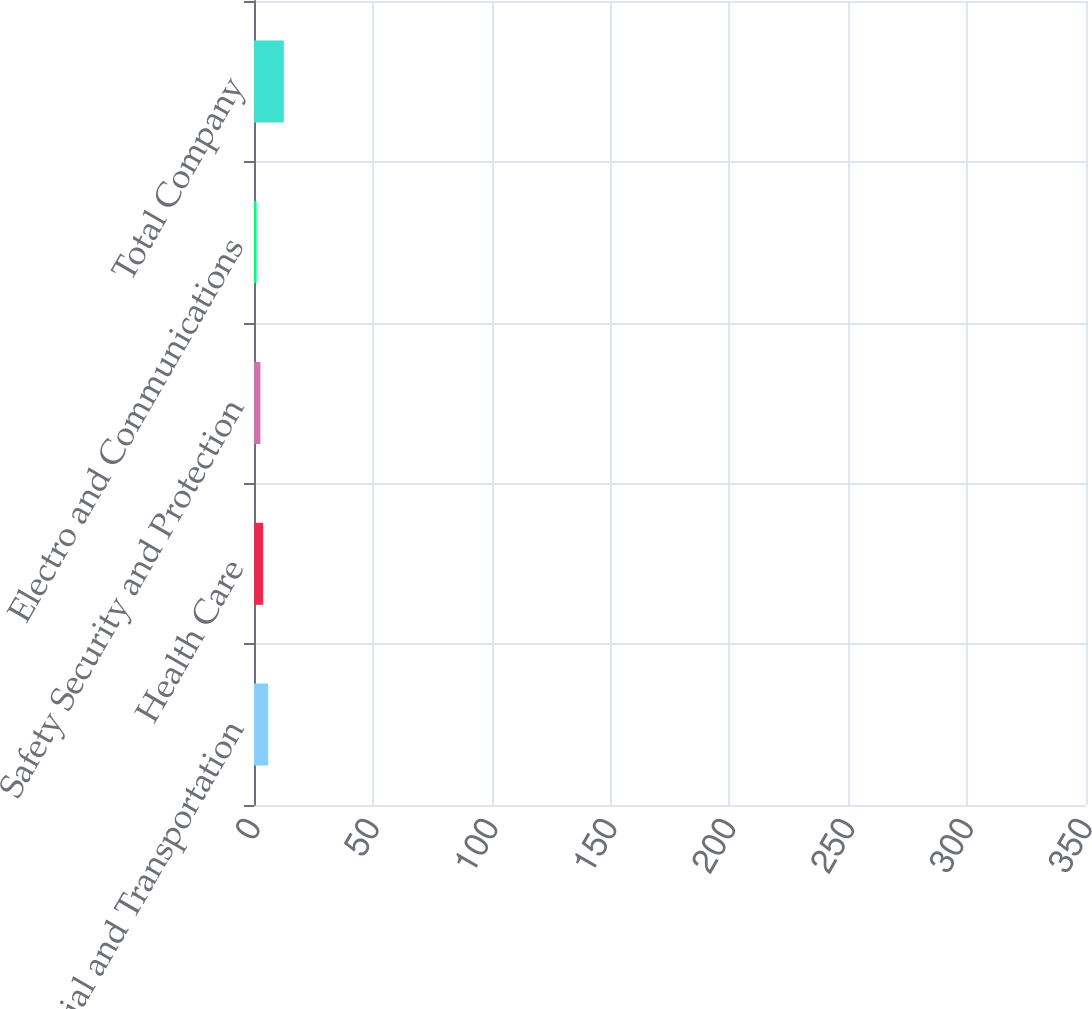Convert chart to OTSL. <chart><loc_0><loc_0><loc_500><loc_500><bar_chart><fcel>Industrial and Transportation<fcel>Health Care<fcel>Safety Security and Protection<fcel>Electro and Communications<fcel>Total Company<nl><fcel>155<fcel>99.8<fcel>70<fcel>28<fcel>326<nl></chart> 